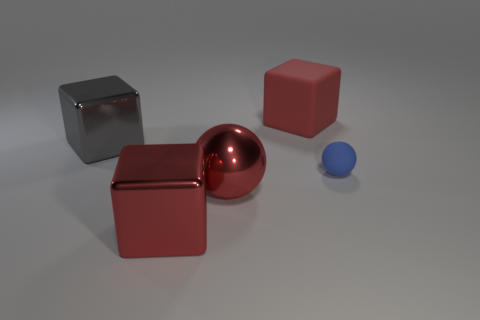Subtract all red blocks. How many blocks are left? 1 Add 3 green rubber spheres. How many objects exist? 8 Subtract all blocks. How many objects are left? 2 Subtract 1 red cubes. How many objects are left? 4 Subtract all big red metal objects. Subtract all big red blocks. How many objects are left? 1 Add 3 metallic blocks. How many metallic blocks are left? 5 Add 4 tiny blue spheres. How many tiny blue spheres exist? 5 